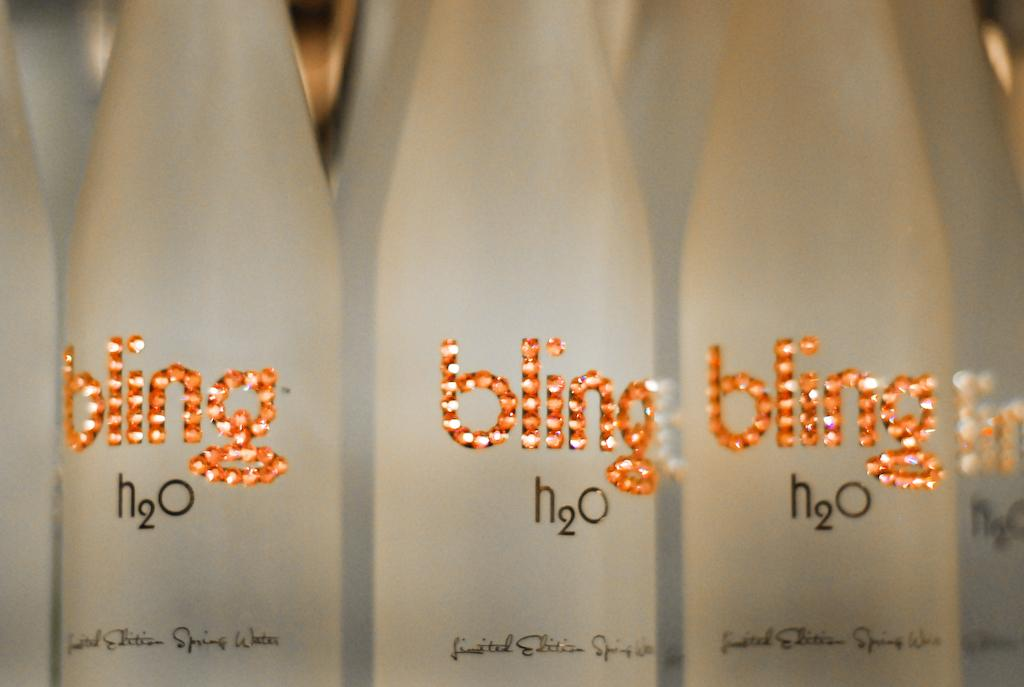<image>
Give a short and clear explanation of the subsequent image. Limited edition bottles of Bling water are on display. 